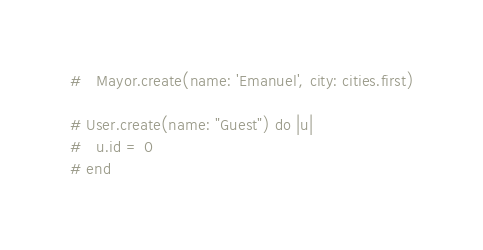Convert code to text. <code><loc_0><loc_0><loc_500><loc_500><_Ruby_>#   Mayor.create(name: 'Emanuel', city: cities.first)

# User.create(name: "Guest") do |u|
#   u.id = 0
# end
</code> 